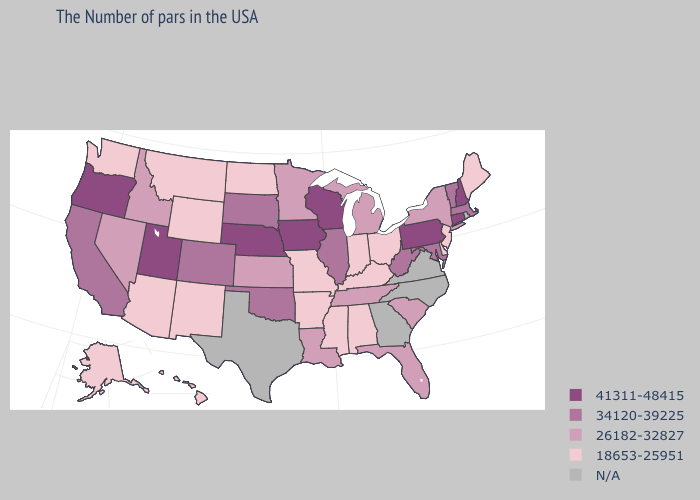Does Delaware have the lowest value in the USA?
Give a very brief answer. Yes. Does the first symbol in the legend represent the smallest category?
Keep it brief. No. Does Alaska have the highest value in the West?
Give a very brief answer. No. Which states have the highest value in the USA?
Answer briefly. New Hampshire, Connecticut, Pennsylvania, Wisconsin, Iowa, Nebraska, Utah, Oregon. Which states hav the highest value in the MidWest?
Give a very brief answer. Wisconsin, Iowa, Nebraska. What is the value of Hawaii?
Be succinct. 18653-25951. Name the states that have a value in the range 34120-39225?
Short answer required. Massachusetts, Vermont, Maryland, West Virginia, Illinois, Oklahoma, South Dakota, Colorado, California. Name the states that have a value in the range 41311-48415?
Short answer required. New Hampshire, Connecticut, Pennsylvania, Wisconsin, Iowa, Nebraska, Utah, Oregon. What is the value of Indiana?
Keep it brief. 18653-25951. Among the states that border Alabama , does Mississippi have the lowest value?
Concise answer only. Yes. Name the states that have a value in the range N/A?
Give a very brief answer. Rhode Island, Virginia, North Carolina, Georgia, Texas. Among the states that border Alabama , does Florida have the lowest value?
Be succinct. No. Among the states that border Virginia , does Kentucky have the lowest value?
Short answer required. Yes. Does Wisconsin have the lowest value in the USA?
Give a very brief answer. No. 